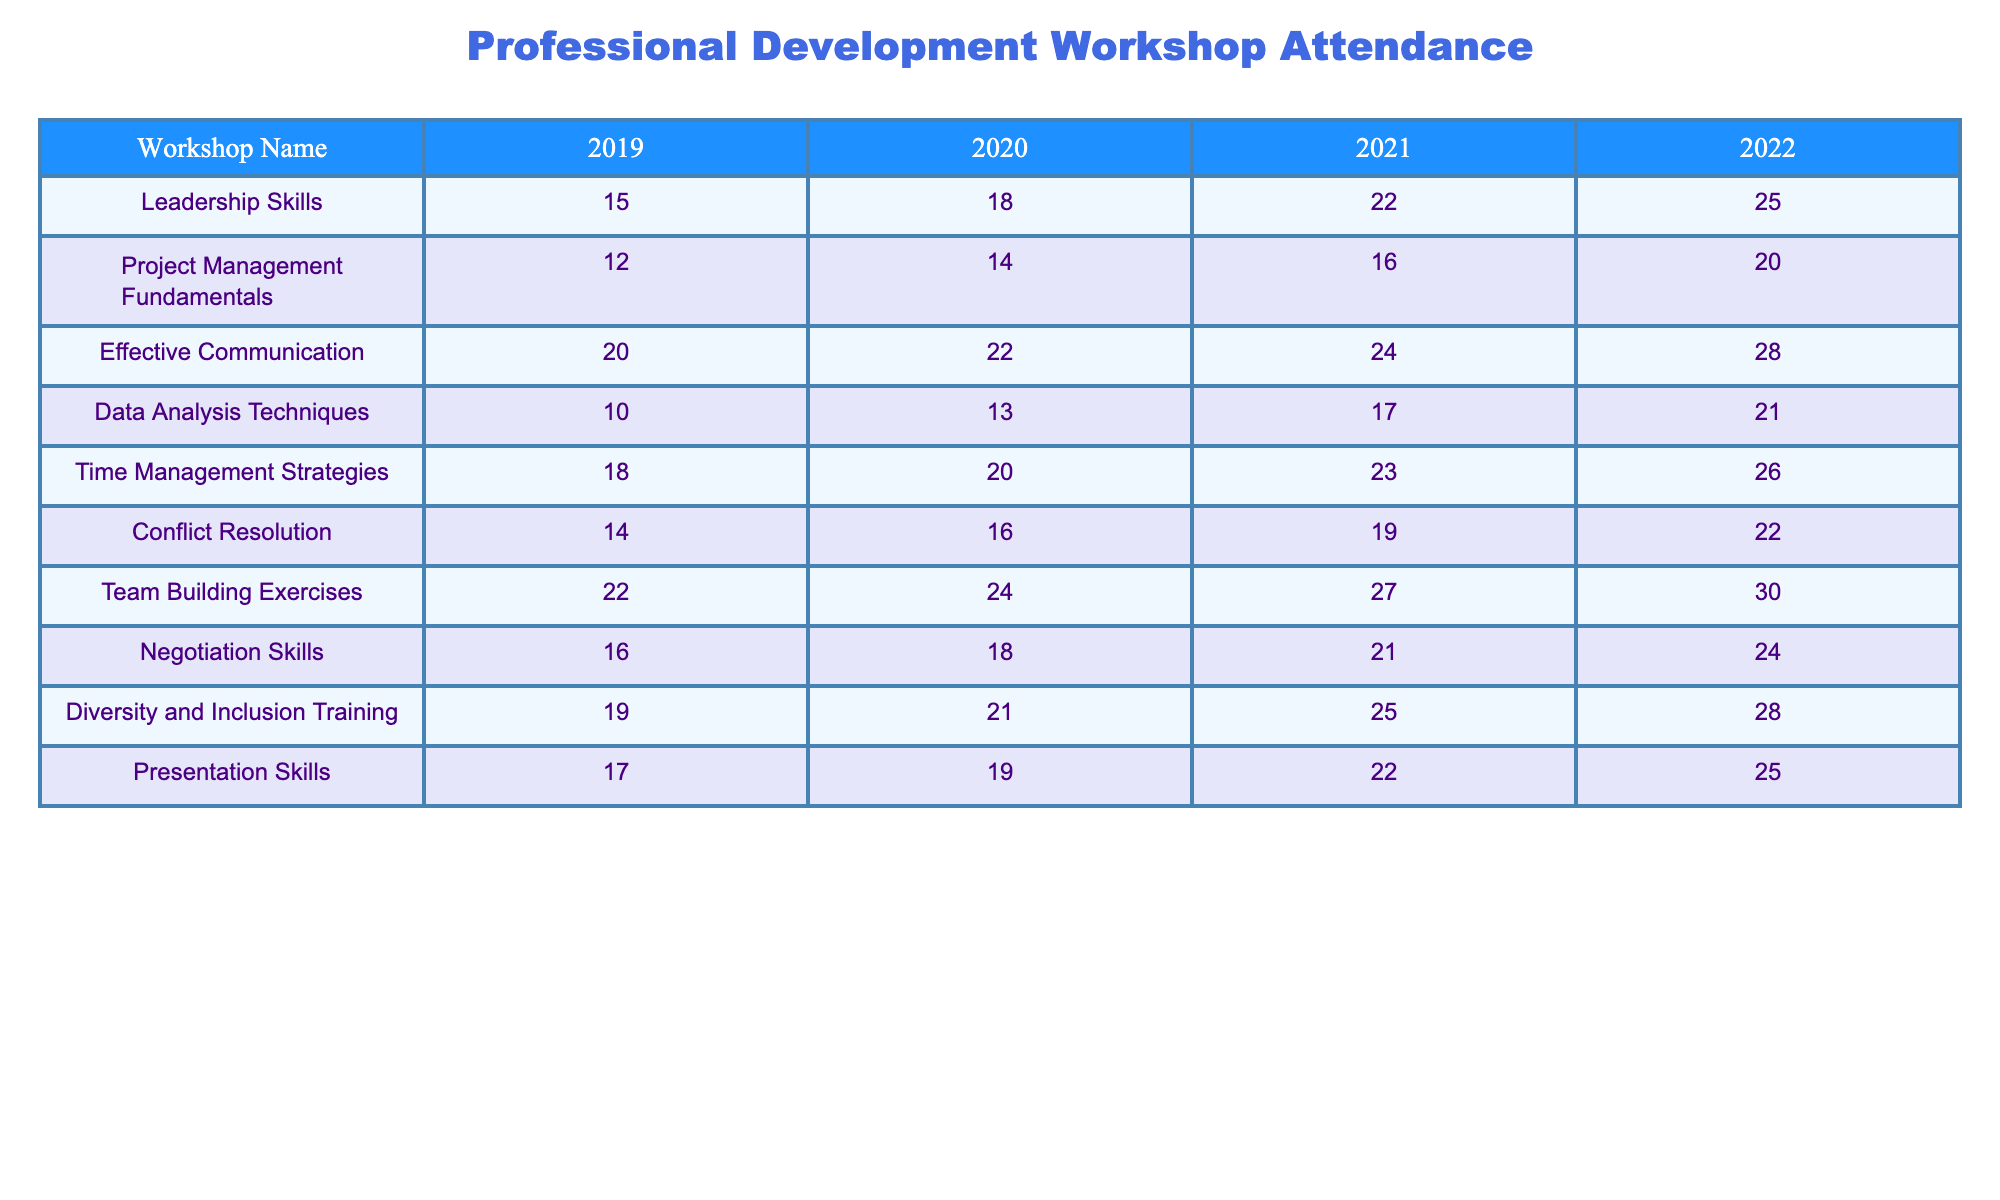What was the attendance for the Leadership Skills workshop in 2021? The table shows that the attendance for the Leadership Skills workshop in the year 2021 is 22.
Answer: 22 Which workshop had the highest attendance in 2022? In 2022, the workshops with attendance numbers are Leadership Skills (25), Project Management Fundamentals (20), Effective Communication (28), Data Analysis Techniques (21), Time Management Strategies (26), Conflict Resolution (22), Team Building Exercises (30), Negotiation Skills (24), Diversity and Inclusion Training (28), and Presentation Skills (25). The highest attendance is for Team Building Exercises with 30 attendees.
Answer: Team Building Exercises What is the average attendance for Effective Communication from 2019 to 2022? To find the average attendance for Effective Communication, we add the attendances from each year: 20 (2019) + 22 (2020) + 24 (2021) + 28 (2022) = 94. There are 4 years, so we divide 94 by 4, resulting in 23.5.
Answer: 23.5 Did the attendance for Time Management Strategies increase every year from 2019 to 2022? The attendance for Time Management Strategies was 18 in 2019, 20 in 2020, 23 in 2021, and 26 in 2022. Since the numbers increase each year, the answer is yes.
Answer: Yes What is the total attendance for all workshops in 2020? The total attendance for all workshops in 2020 can be calculated by adding the numbers from each workshop: 18 (Leadership Skills) + 14 + 22 + 13 + 20 + 16 + 24 + 18 + 21 + 19 = 205.
Answer: 205 Which workshop saw the smallest increase in attendance from 2019 to 2022? We calculate the attendance change for each workshop: Leadership Skills (10) + 7 = 15, Project Management Fundamentals (12) + 8 = 8, Effective Communication (20) + 8 = 8, Data Analysis Techniques (10) + 11 = 11, Time Management Strategies (18) + 8 = 8, Conflict Resolution (14) + 8 = 8, Team Building Exercises (22) + 8 = 8, Negotiation Skills (16) + 8 = 8, Diversity and Inclusion Training (19) + 9 = 9, Presentation Skills (17) + 8 = 8. So, Data Analysis Techniques had the smallest increase in attendance.
Answer: Data Analysis Techniques In which year did Diversity and Inclusion Training have the same attendance as Negotiation Skills? The table indicates the attendance: Diversity and Inclusion Training had 19 in 2019, 21 in 2020, 25 in 2021, and 28 in 2022. Negotiation Skills had 16 in 2019, 18 in 2020, 21 in 2021, and 24 in 2022. The two workshops had the same attendance in 2021 with 21 attendees.
Answer: 2021 Which workshop consistently had attendance numbers above 20 for all years? Evaluating the attendance, Team Building Exercises (22, 24, 27, 30) and Effective Communication (20, 22, 24, 28) both had attendances above 20 for all years surveyed. The first consistently above 20 is Team Building Exercises.
Answer: Team Building Exercises 